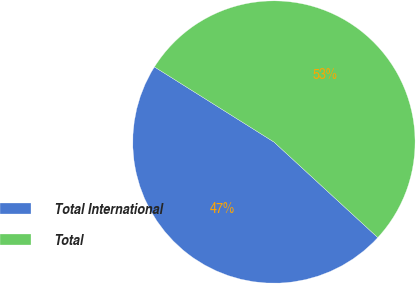Convert chart to OTSL. <chart><loc_0><loc_0><loc_500><loc_500><pie_chart><fcel>Total International<fcel>Total<nl><fcel>47.09%<fcel>52.91%<nl></chart> 